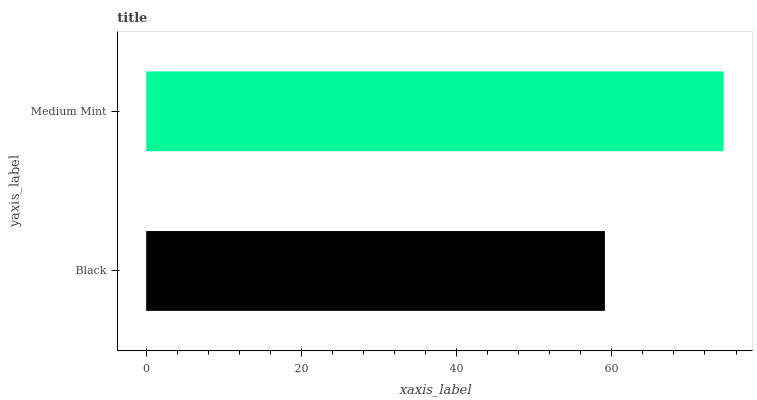Is Black the minimum?
Answer yes or no. Yes. Is Medium Mint the maximum?
Answer yes or no. Yes. Is Medium Mint the minimum?
Answer yes or no. No. Is Medium Mint greater than Black?
Answer yes or no. Yes. Is Black less than Medium Mint?
Answer yes or no. Yes. Is Black greater than Medium Mint?
Answer yes or no. No. Is Medium Mint less than Black?
Answer yes or no. No. Is Medium Mint the high median?
Answer yes or no. Yes. Is Black the low median?
Answer yes or no. Yes. Is Black the high median?
Answer yes or no. No. Is Medium Mint the low median?
Answer yes or no. No. 